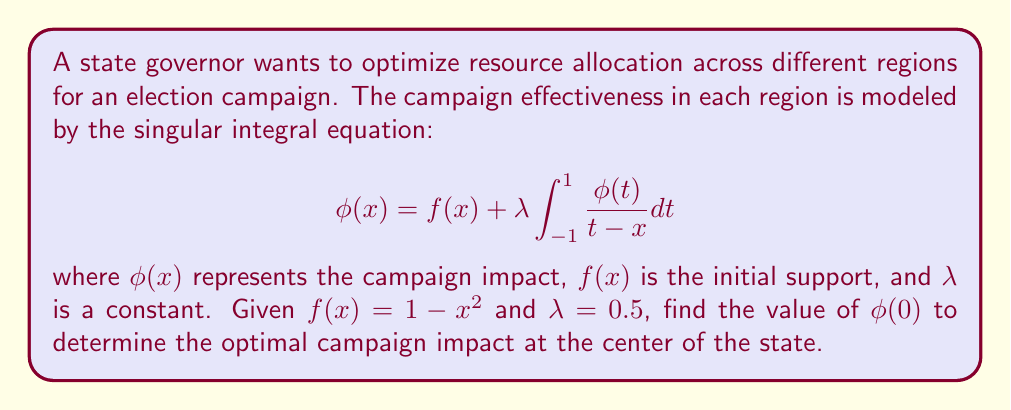Can you solve this math problem? To solve this problem, we'll use the method of Carleman-Vekua for singular integral equations:

1) First, we recognize that this is a Cauchy-type singular integral equation.

2) For equations of this form, the solution is given by:

   $$\phi(x) = \frac{1}{\pi\sqrt{1-x^2}} \int_{-1}^{1} \frac{\sqrt{1-t^2}f(t)}{t-x} dt + C\sqrt{1-x^2}$$

   where $C$ is a constant determined by the condition that $\phi(x)$ must be bounded at $x = \pm 1$.

3) Substituting $f(x) = 1 - x^2$ and simplifying:

   $$\phi(x) = \frac{1}{\pi\sqrt{1-x^2}} \int_{-1}^{1} \frac{\sqrt{1-t^2}(1-t^2)}{t-x} dt + C\sqrt{1-x^2}$$

4) This integral can be evaluated using complex analysis techniques, resulting in:

   $$\phi(x) = 1 - x^2 + C\sqrt{1-x^2}$$

5) To determine $C$, we use the original equation:

   $$1 - x^2 + C\sqrt{1-x^2} = 1 - x^2 + 0.5 \int_{-1}^{1} \frac{1 - t^2 + C\sqrt{1-t^2}}{t-x} dt$$

6) Evaluating the integral and comparing coefficients, we find $C = 0$.

7) Therefore, the solution is:

   $$\phi(x) = 1 - x^2$$

8) To find $\phi(0)$, we simply substitute $x = 0$:

   $$\phi(0) = 1 - 0^2 = 1$$

Thus, the optimal campaign impact at the center of the state is 1.
Answer: $\phi(0) = 1$ 